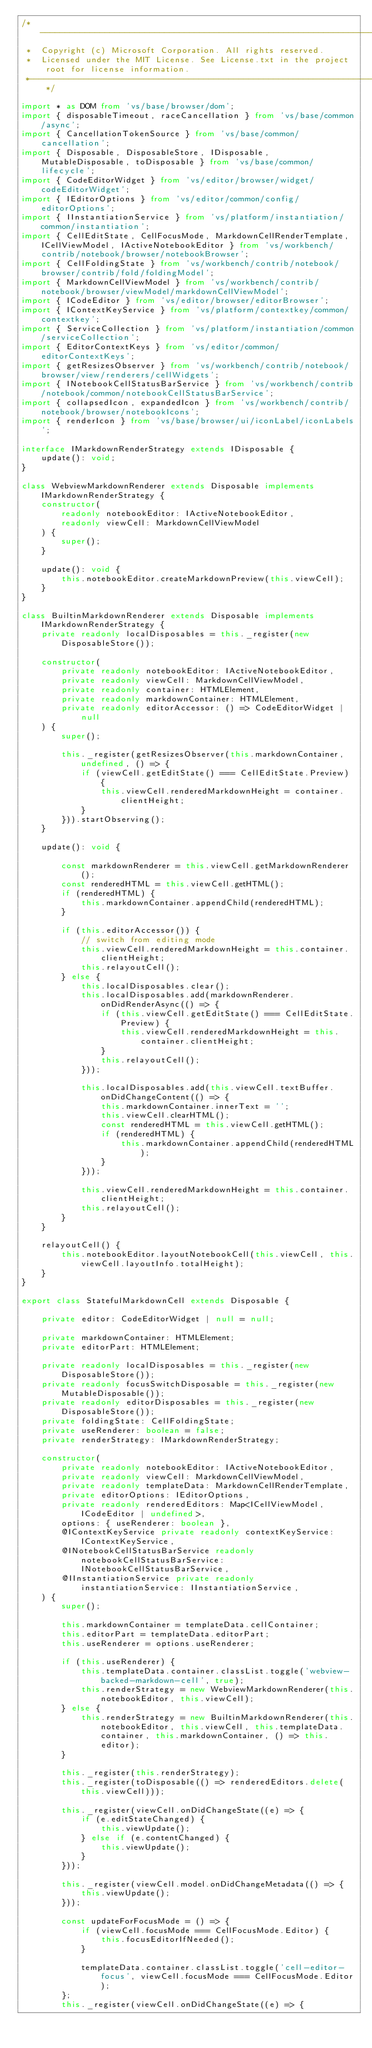<code> <loc_0><loc_0><loc_500><loc_500><_TypeScript_>/*---------------------------------------------------------------------------------------------
 *  Copyright (c) Microsoft Corporation. All rights reserved.
 *  Licensed under the MIT License. See License.txt in the project root for license information.
 *--------------------------------------------------------------------------------------------*/

import * as DOM from 'vs/base/browser/dom';
import { disposableTimeout, raceCancellation } from 'vs/base/common/async';
import { CancellationTokenSource } from 'vs/base/common/cancellation';
import { Disposable, DisposableStore, IDisposable, MutableDisposable, toDisposable } from 'vs/base/common/lifecycle';
import { CodeEditorWidget } from 'vs/editor/browser/widget/codeEditorWidget';
import { IEditorOptions } from 'vs/editor/common/config/editorOptions';
import { IInstantiationService } from 'vs/platform/instantiation/common/instantiation';
import { CellEditState, CellFocusMode, MarkdownCellRenderTemplate, ICellViewModel, IActiveNotebookEditor } from 'vs/workbench/contrib/notebook/browser/notebookBrowser';
import { CellFoldingState } from 'vs/workbench/contrib/notebook/browser/contrib/fold/foldingModel';
import { MarkdownCellViewModel } from 'vs/workbench/contrib/notebook/browser/viewModel/markdownCellViewModel';
import { ICodeEditor } from 'vs/editor/browser/editorBrowser';
import { IContextKeyService } from 'vs/platform/contextkey/common/contextkey';
import { ServiceCollection } from 'vs/platform/instantiation/common/serviceCollection';
import { EditorContextKeys } from 'vs/editor/common/editorContextKeys';
import { getResizesObserver } from 'vs/workbench/contrib/notebook/browser/view/renderers/cellWidgets';
import { INotebookCellStatusBarService } from 'vs/workbench/contrib/notebook/common/notebookCellStatusBarService';
import { collapsedIcon, expandedIcon } from 'vs/workbench/contrib/notebook/browser/notebookIcons';
import { renderIcon } from 'vs/base/browser/ui/iconLabel/iconLabels';

interface IMarkdownRenderStrategy extends IDisposable {
	update(): void;
}

class WebviewMarkdownRenderer extends Disposable implements IMarkdownRenderStrategy {
	constructor(
		readonly notebookEditor: IActiveNotebookEditor,
		readonly viewCell: MarkdownCellViewModel
	) {
		super();
	}

	update(): void {
		this.notebookEditor.createMarkdownPreview(this.viewCell);
	}
}

class BuiltinMarkdownRenderer extends Disposable implements IMarkdownRenderStrategy {
	private readonly localDisposables = this._register(new DisposableStore());

	constructor(
		private readonly notebookEditor: IActiveNotebookEditor,
		private readonly viewCell: MarkdownCellViewModel,
		private readonly container: HTMLElement,
		private readonly markdownContainer: HTMLElement,
		private readonly editorAccessor: () => CodeEditorWidget | null
	) {
		super();

		this._register(getResizesObserver(this.markdownContainer, undefined, () => {
			if (viewCell.getEditState() === CellEditState.Preview) {
				this.viewCell.renderedMarkdownHeight = container.clientHeight;
			}
		})).startObserving();
	}

	update(): void {

		const markdownRenderer = this.viewCell.getMarkdownRenderer();
		const renderedHTML = this.viewCell.getHTML();
		if (renderedHTML) {
			this.markdownContainer.appendChild(renderedHTML);
		}

		if (this.editorAccessor()) {
			// switch from editing mode
			this.viewCell.renderedMarkdownHeight = this.container.clientHeight;
			this.relayoutCell();
		} else {
			this.localDisposables.clear();
			this.localDisposables.add(markdownRenderer.onDidRenderAsync(() => {
				if (this.viewCell.getEditState() === CellEditState.Preview) {
					this.viewCell.renderedMarkdownHeight = this.container.clientHeight;
				}
				this.relayoutCell();
			}));

			this.localDisposables.add(this.viewCell.textBuffer.onDidChangeContent(() => {
				this.markdownContainer.innerText = '';
				this.viewCell.clearHTML();
				const renderedHTML = this.viewCell.getHTML();
				if (renderedHTML) {
					this.markdownContainer.appendChild(renderedHTML);
				}
			}));

			this.viewCell.renderedMarkdownHeight = this.container.clientHeight;
			this.relayoutCell();
		}
	}

	relayoutCell() {
		this.notebookEditor.layoutNotebookCell(this.viewCell, this.viewCell.layoutInfo.totalHeight);
	}
}

export class StatefulMarkdownCell extends Disposable {

	private editor: CodeEditorWidget | null = null;

	private markdownContainer: HTMLElement;
	private editorPart: HTMLElement;

	private readonly localDisposables = this._register(new DisposableStore());
	private readonly focusSwitchDisposable = this._register(new MutableDisposable());
	private readonly editorDisposables = this._register(new DisposableStore());
	private foldingState: CellFoldingState;
	private useRenderer: boolean = false;
	private renderStrategy: IMarkdownRenderStrategy;

	constructor(
		private readonly notebookEditor: IActiveNotebookEditor,
		private readonly viewCell: MarkdownCellViewModel,
		private readonly templateData: MarkdownCellRenderTemplate,
		private editorOptions: IEditorOptions,
		private readonly renderedEditors: Map<ICellViewModel, ICodeEditor | undefined>,
		options: { useRenderer: boolean },
		@IContextKeyService private readonly contextKeyService: IContextKeyService,
		@INotebookCellStatusBarService readonly notebookCellStatusBarService: INotebookCellStatusBarService,
		@IInstantiationService private readonly instantiationService: IInstantiationService,
	) {
		super();

		this.markdownContainer = templateData.cellContainer;
		this.editorPart = templateData.editorPart;
		this.useRenderer = options.useRenderer;

		if (this.useRenderer) {
			this.templateData.container.classList.toggle('webview-backed-markdown-cell', true);
			this.renderStrategy = new WebviewMarkdownRenderer(this.notebookEditor, this.viewCell);
		} else {
			this.renderStrategy = new BuiltinMarkdownRenderer(this.notebookEditor, this.viewCell, this.templateData.container, this.markdownContainer, () => this.editor);
		}

		this._register(this.renderStrategy);
		this._register(toDisposable(() => renderedEditors.delete(this.viewCell)));

		this._register(viewCell.onDidChangeState((e) => {
			if (e.editStateChanged) {
				this.viewUpdate();
			} else if (e.contentChanged) {
				this.viewUpdate();
			}
		}));

		this._register(viewCell.model.onDidChangeMetadata(() => {
			this.viewUpdate();
		}));

		const updateForFocusMode = () => {
			if (viewCell.focusMode === CellFocusMode.Editor) {
				this.focusEditorIfNeeded();
			}

			templateData.container.classList.toggle('cell-editor-focus', viewCell.focusMode === CellFocusMode.Editor);
		};
		this._register(viewCell.onDidChangeState((e) => {</code> 